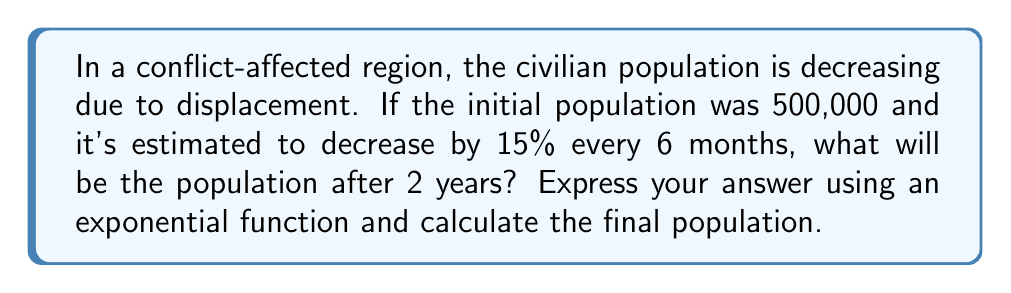Solve this math problem. Let's approach this step-by-step:

1) First, we need to identify the components of our exponential function:
   - Initial population (P₀) = 500,000
   - Rate of decrease (r) = 15% = 0.15
   - Time period (t) = 2 years
   - Number of times the rate is applied (n) = 4 (because it's every 6 months, so 4 times in 2 years)

2) The general form of an exponential decay function is:
   $$ P(t) = P_0(1-r)^n $$

3) Substituting our values:
   $$ P(2) = 500,000(1-0.15)^4 $$

4) Simplify inside the parentheses:
   $$ P(2) = 500,000(0.85)^4 $$

5) Calculate $(0.85)^4$:
   $$ (0.85)^4 = 0.5220 \text{ (rounded to 4 decimal places)} $$

6) Multiply:
   $$ P(2) = 500,000 \times 0.5220 = 261,000 \text{ (rounded to nearest thousand)} $$

Therefore, after 2 years, the population will be approximately 261,000.
Answer: $P(2) = 500,000(0.85)^4 \approx 261,000$ 